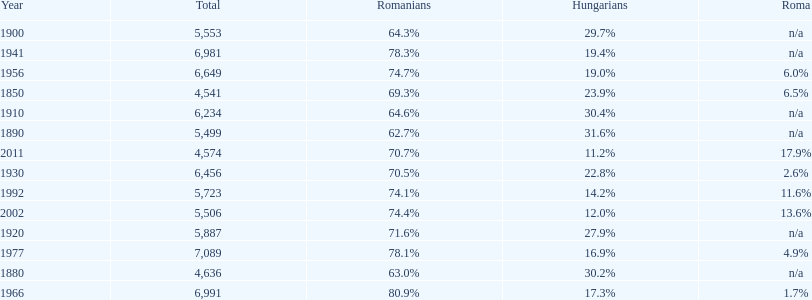Which year had the top percentage in romanian population? 1966. 